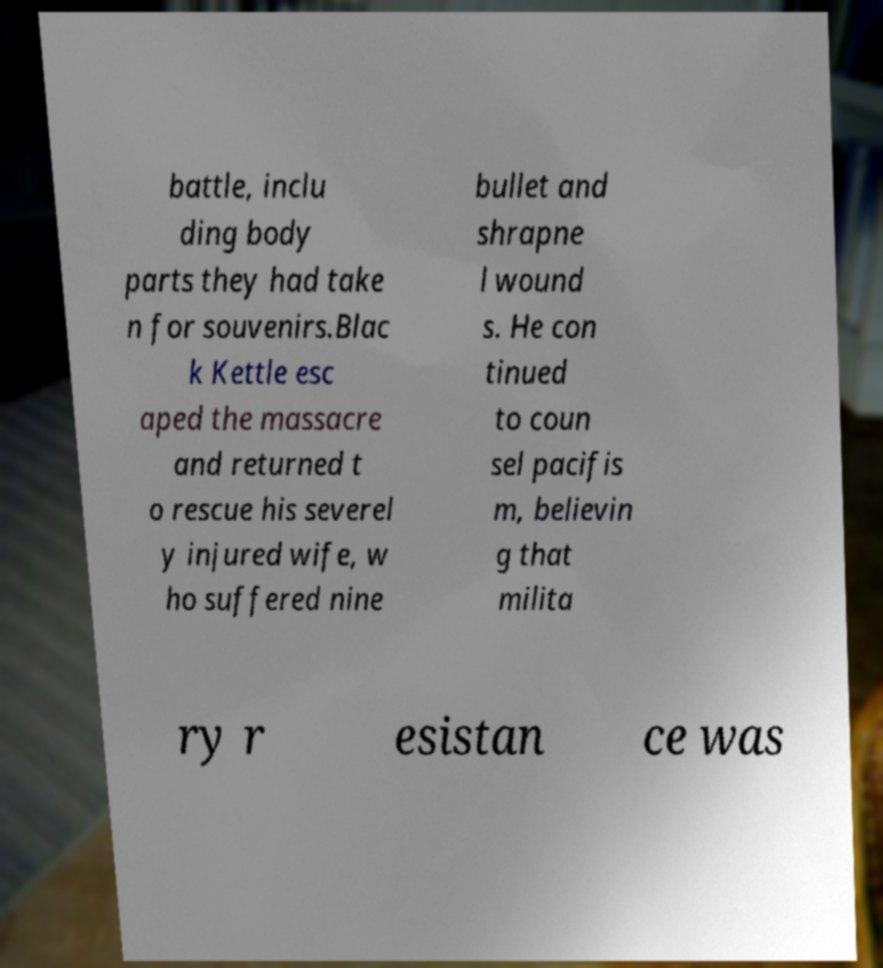For documentation purposes, I need the text within this image transcribed. Could you provide that? battle, inclu ding body parts they had take n for souvenirs.Blac k Kettle esc aped the massacre and returned t o rescue his severel y injured wife, w ho suffered nine bullet and shrapne l wound s. He con tinued to coun sel pacifis m, believin g that milita ry r esistan ce was 